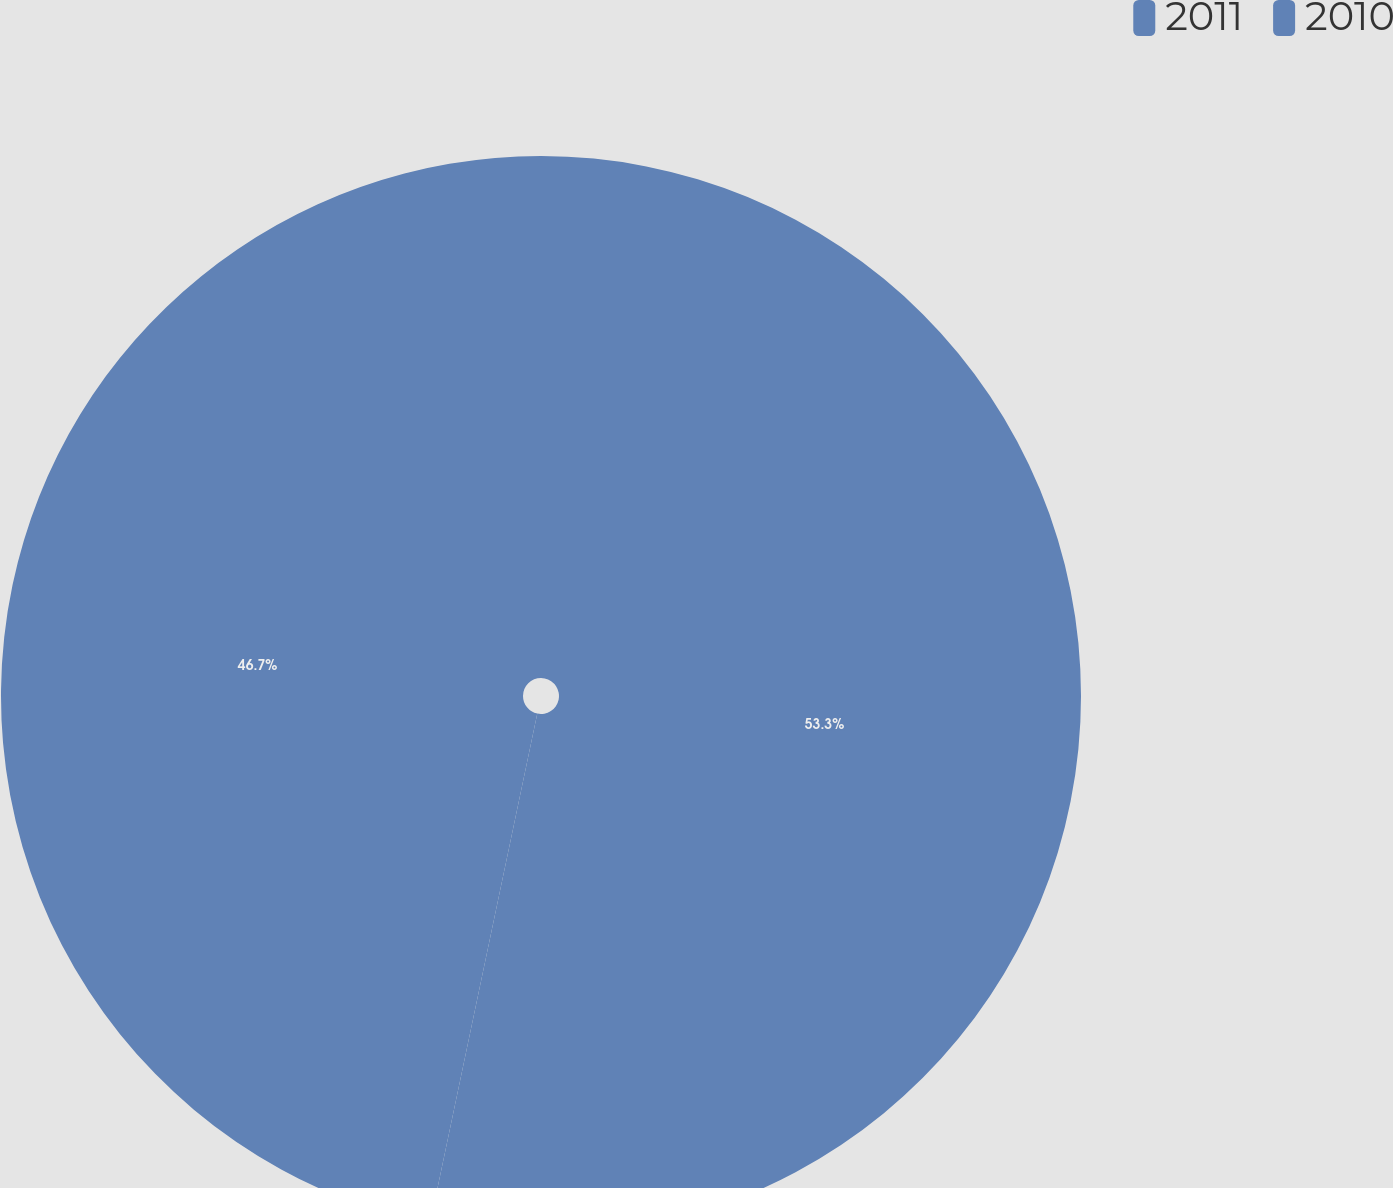Convert chart. <chart><loc_0><loc_0><loc_500><loc_500><pie_chart><fcel>2011<fcel>2010<nl><fcel>53.3%<fcel>46.7%<nl></chart> 